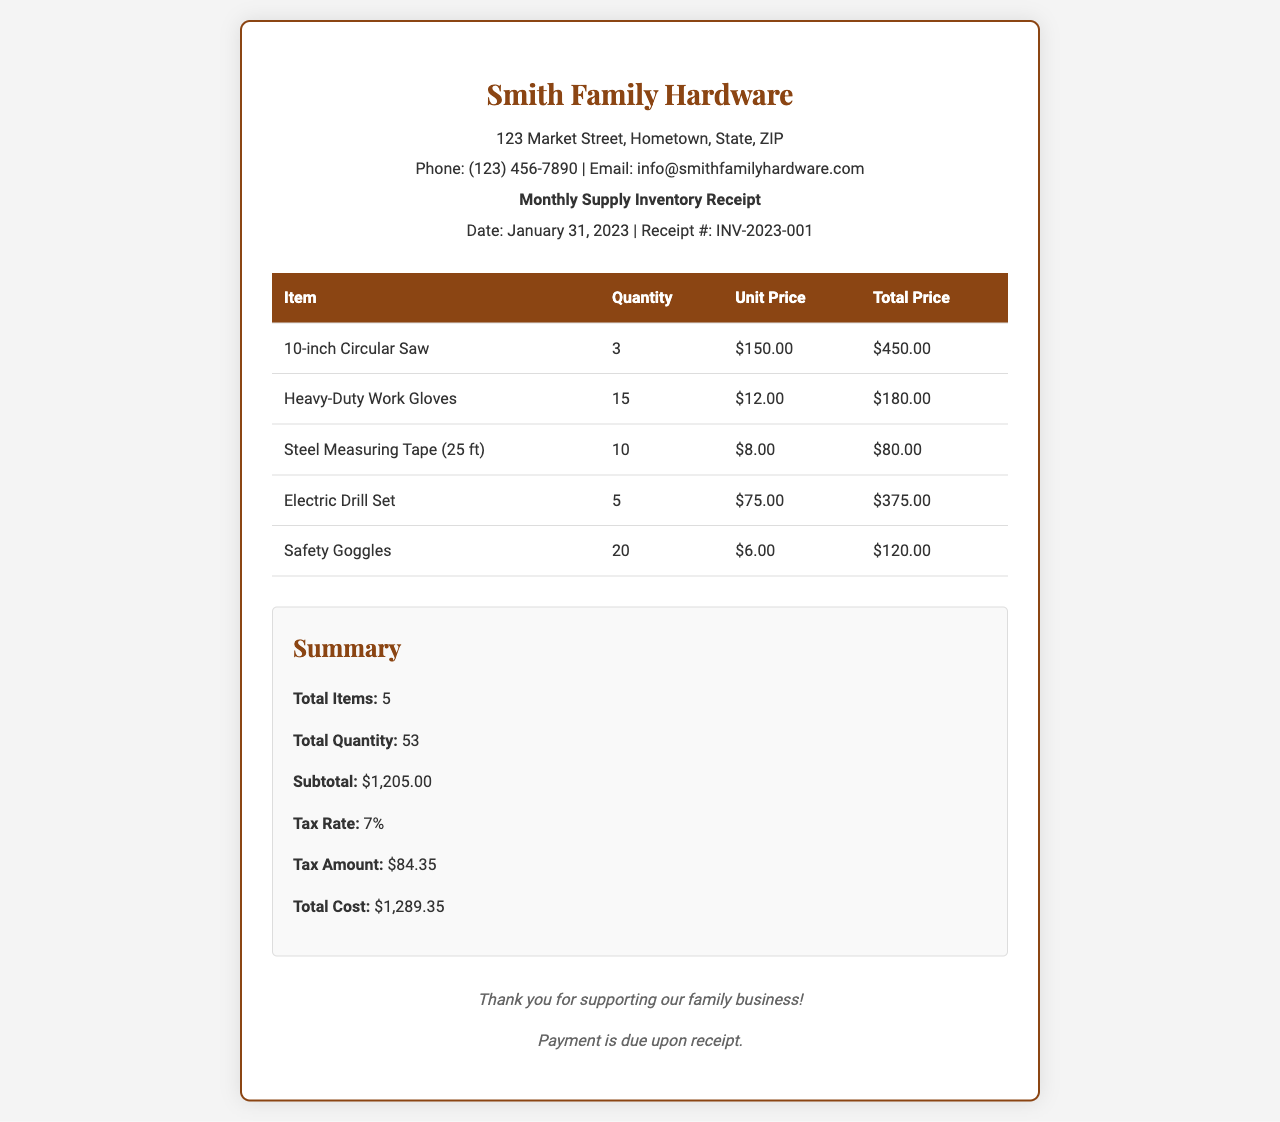What is the receipt date? The receipt date is stated in the header, which is January 31, 2023.
Answer: January 31, 2023 What is the total cost? The total cost can be found in the summary section, which lists the total cost as $1,289.35.
Answer: $1,289.35 How many items were purchased? The total number of items purchased is listed in the summary as 5.
Answer: 5 What is the quantity of Electric Drill Sets? The quantity for Electric Drill Sets is indicated in the itemized list, which shows 5 units.
Answer: 5 What is the tax amount? The tax amount is provided in the summary section, noted as $84.35.
Answer: $84.35 What is the total quantity of all items? The total quantity of all items is summarized as 53.
Answer: 53 What is the name of the business on the receipt? The business name appears at the top of the receipt, identified as Smith Family Hardware.
Answer: Smith Family Hardware What is the unit price of Heavy-Duty Work Gloves? The unit price for Heavy-Duty Work Gloves is mentioned in the itemized list as $12.00.
Answer: $12.00 What is the address of the business? The address is provided in the header of the receipt, which reads 123 Market Street, Hometown, State, ZIP.
Answer: 123 Market Street, Hometown, State, ZIP 